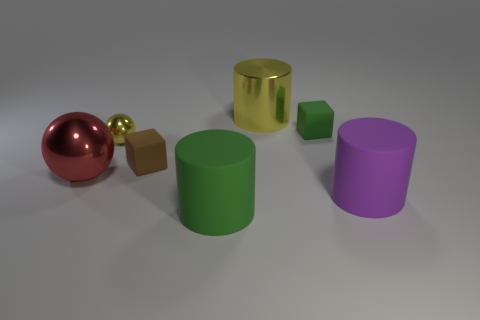Add 2 metal cylinders. How many objects exist? 9 Subtract all blocks. How many objects are left? 5 Add 3 small blue metallic balls. How many small blue metallic balls exist? 3 Subtract 0 red cylinders. How many objects are left? 7 Subtract all yellow shiny balls. Subtract all red metal objects. How many objects are left? 5 Add 2 tiny green matte objects. How many tiny green matte objects are left? 3 